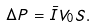<formula> <loc_0><loc_0><loc_500><loc_500>\Delta P = \bar { I } V _ { 0 } S .</formula> 